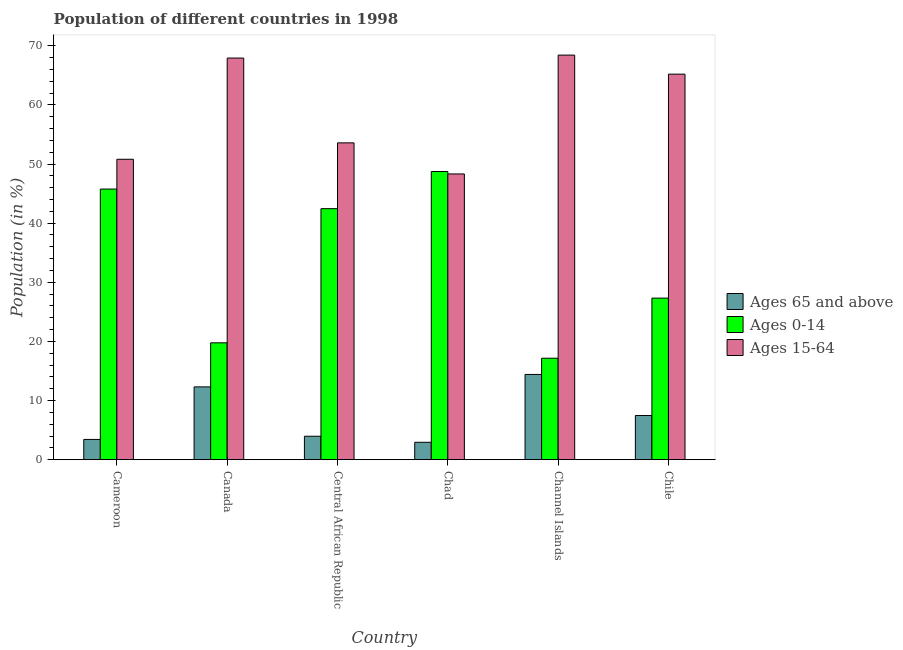How many different coloured bars are there?
Make the answer very short. 3. Are the number of bars on each tick of the X-axis equal?
Your answer should be compact. Yes. What is the label of the 4th group of bars from the left?
Provide a short and direct response. Chad. In how many cases, is the number of bars for a given country not equal to the number of legend labels?
Your answer should be compact. 0. What is the percentage of population within the age-group 15-64 in Chad?
Keep it short and to the point. 48.32. Across all countries, what is the maximum percentage of population within the age-group 15-64?
Provide a short and direct response. 68.42. Across all countries, what is the minimum percentage of population within the age-group 15-64?
Give a very brief answer. 48.32. In which country was the percentage of population within the age-group 15-64 maximum?
Provide a succinct answer. Channel Islands. In which country was the percentage of population within the age-group of 65 and above minimum?
Make the answer very short. Chad. What is the total percentage of population within the age-group of 65 and above in the graph?
Offer a very short reply. 44.55. What is the difference between the percentage of population within the age-group of 65 and above in Chad and that in Channel Islands?
Make the answer very short. -11.47. What is the difference between the percentage of population within the age-group of 65 and above in Chile and the percentage of population within the age-group 0-14 in Central African Republic?
Provide a short and direct response. -34.98. What is the average percentage of population within the age-group 0-14 per country?
Make the answer very short. 33.53. What is the difference between the percentage of population within the age-group of 65 and above and percentage of population within the age-group 15-64 in Canada?
Ensure brevity in your answer.  -55.61. In how many countries, is the percentage of population within the age-group 0-14 greater than 62 %?
Your answer should be compact. 0. What is the ratio of the percentage of population within the age-group 15-64 in Cameroon to that in Central African Republic?
Give a very brief answer. 0.95. Is the difference between the percentage of population within the age-group 0-14 in Cameroon and Chad greater than the difference between the percentage of population within the age-group of 65 and above in Cameroon and Chad?
Provide a short and direct response. No. What is the difference between the highest and the second highest percentage of population within the age-group of 65 and above?
Your response must be concise. 2.11. What is the difference between the highest and the lowest percentage of population within the age-group of 65 and above?
Offer a very short reply. 11.47. What does the 1st bar from the left in Cameroon represents?
Your answer should be very brief. Ages 65 and above. What does the 1st bar from the right in Channel Islands represents?
Provide a succinct answer. Ages 15-64. Are all the bars in the graph horizontal?
Provide a short and direct response. No. How many countries are there in the graph?
Ensure brevity in your answer.  6. Does the graph contain any zero values?
Keep it short and to the point. No. Does the graph contain grids?
Keep it short and to the point. No. What is the title of the graph?
Your response must be concise. Population of different countries in 1998. Does "Infant(male)" appear as one of the legend labels in the graph?
Offer a very short reply. No. What is the Population (in %) in Ages 65 and above in Cameroon?
Provide a succinct answer. 3.43. What is the Population (in %) in Ages 0-14 in Cameroon?
Ensure brevity in your answer.  45.77. What is the Population (in %) of Ages 15-64 in Cameroon?
Offer a terse response. 50.8. What is the Population (in %) of Ages 65 and above in Canada?
Provide a succinct answer. 12.31. What is the Population (in %) of Ages 0-14 in Canada?
Offer a very short reply. 19.76. What is the Population (in %) of Ages 15-64 in Canada?
Provide a short and direct response. 67.92. What is the Population (in %) of Ages 65 and above in Central African Republic?
Keep it short and to the point. 3.97. What is the Population (in %) of Ages 0-14 in Central African Republic?
Ensure brevity in your answer.  42.45. What is the Population (in %) of Ages 15-64 in Central African Republic?
Offer a terse response. 53.58. What is the Population (in %) in Ages 65 and above in Chad?
Keep it short and to the point. 2.94. What is the Population (in %) in Ages 0-14 in Chad?
Your answer should be compact. 48.73. What is the Population (in %) of Ages 15-64 in Chad?
Your answer should be compact. 48.32. What is the Population (in %) in Ages 65 and above in Channel Islands?
Provide a succinct answer. 14.42. What is the Population (in %) of Ages 0-14 in Channel Islands?
Ensure brevity in your answer.  17.16. What is the Population (in %) of Ages 15-64 in Channel Islands?
Provide a succinct answer. 68.42. What is the Population (in %) in Ages 65 and above in Chile?
Ensure brevity in your answer.  7.48. What is the Population (in %) of Ages 0-14 in Chile?
Offer a terse response. 27.32. What is the Population (in %) in Ages 15-64 in Chile?
Your response must be concise. 65.2. Across all countries, what is the maximum Population (in %) in Ages 65 and above?
Ensure brevity in your answer.  14.42. Across all countries, what is the maximum Population (in %) in Ages 0-14?
Your response must be concise. 48.73. Across all countries, what is the maximum Population (in %) in Ages 15-64?
Keep it short and to the point. 68.42. Across all countries, what is the minimum Population (in %) in Ages 65 and above?
Make the answer very short. 2.94. Across all countries, what is the minimum Population (in %) in Ages 0-14?
Keep it short and to the point. 17.16. Across all countries, what is the minimum Population (in %) of Ages 15-64?
Offer a terse response. 48.32. What is the total Population (in %) in Ages 65 and above in the graph?
Your answer should be compact. 44.55. What is the total Population (in %) of Ages 0-14 in the graph?
Provide a short and direct response. 201.2. What is the total Population (in %) in Ages 15-64 in the graph?
Your answer should be very brief. 354.25. What is the difference between the Population (in %) in Ages 65 and above in Cameroon and that in Canada?
Give a very brief answer. -8.89. What is the difference between the Population (in %) of Ages 0-14 in Cameroon and that in Canada?
Offer a terse response. 26. What is the difference between the Population (in %) of Ages 15-64 in Cameroon and that in Canada?
Offer a terse response. -17.12. What is the difference between the Population (in %) in Ages 65 and above in Cameroon and that in Central African Republic?
Offer a very short reply. -0.54. What is the difference between the Population (in %) in Ages 0-14 in Cameroon and that in Central African Republic?
Your answer should be compact. 3.32. What is the difference between the Population (in %) in Ages 15-64 in Cameroon and that in Central African Republic?
Your answer should be compact. -2.78. What is the difference between the Population (in %) of Ages 65 and above in Cameroon and that in Chad?
Provide a succinct answer. 0.48. What is the difference between the Population (in %) of Ages 0-14 in Cameroon and that in Chad?
Your response must be concise. -2.96. What is the difference between the Population (in %) of Ages 15-64 in Cameroon and that in Chad?
Your answer should be very brief. 2.48. What is the difference between the Population (in %) of Ages 65 and above in Cameroon and that in Channel Islands?
Provide a short and direct response. -10.99. What is the difference between the Population (in %) of Ages 0-14 in Cameroon and that in Channel Islands?
Your answer should be very brief. 28.61. What is the difference between the Population (in %) in Ages 15-64 in Cameroon and that in Channel Islands?
Your answer should be compact. -17.62. What is the difference between the Population (in %) of Ages 65 and above in Cameroon and that in Chile?
Provide a short and direct response. -4.05. What is the difference between the Population (in %) of Ages 0-14 in Cameroon and that in Chile?
Ensure brevity in your answer.  18.44. What is the difference between the Population (in %) in Ages 15-64 in Cameroon and that in Chile?
Give a very brief answer. -14.39. What is the difference between the Population (in %) in Ages 65 and above in Canada and that in Central African Republic?
Provide a succinct answer. 8.35. What is the difference between the Population (in %) of Ages 0-14 in Canada and that in Central African Republic?
Make the answer very short. -22.69. What is the difference between the Population (in %) of Ages 15-64 in Canada and that in Central African Republic?
Provide a short and direct response. 14.34. What is the difference between the Population (in %) of Ages 65 and above in Canada and that in Chad?
Give a very brief answer. 9.37. What is the difference between the Population (in %) in Ages 0-14 in Canada and that in Chad?
Ensure brevity in your answer.  -28.97. What is the difference between the Population (in %) of Ages 15-64 in Canada and that in Chad?
Make the answer very short. 19.6. What is the difference between the Population (in %) in Ages 65 and above in Canada and that in Channel Islands?
Your answer should be very brief. -2.1. What is the difference between the Population (in %) in Ages 0-14 in Canada and that in Channel Islands?
Your answer should be compact. 2.6. What is the difference between the Population (in %) of Ages 15-64 in Canada and that in Channel Islands?
Your response must be concise. -0.5. What is the difference between the Population (in %) in Ages 65 and above in Canada and that in Chile?
Keep it short and to the point. 4.84. What is the difference between the Population (in %) of Ages 0-14 in Canada and that in Chile?
Provide a succinct answer. -7.56. What is the difference between the Population (in %) in Ages 15-64 in Canada and that in Chile?
Your answer should be very brief. 2.72. What is the difference between the Population (in %) in Ages 65 and above in Central African Republic and that in Chad?
Your answer should be compact. 1.02. What is the difference between the Population (in %) of Ages 0-14 in Central African Republic and that in Chad?
Offer a very short reply. -6.28. What is the difference between the Population (in %) of Ages 15-64 in Central African Republic and that in Chad?
Your response must be concise. 5.26. What is the difference between the Population (in %) of Ages 65 and above in Central African Republic and that in Channel Islands?
Your answer should be compact. -10.45. What is the difference between the Population (in %) in Ages 0-14 in Central African Republic and that in Channel Islands?
Your response must be concise. 25.29. What is the difference between the Population (in %) in Ages 15-64 in Central African Republic and that in Channel Islands?
Your answer should be compact. -14.84. What is the difference between the Population (in %) in Ages 65 and above in Central African Republic and that in Chile?
Make the answer very short. -3.51. What is the difference between the Population (in %) of Ages 0-14 in Central African Republic and that in Chile?
Offer a terse response. 15.13. What is the difference between the Population (in %) of Ages 15-64 in Central African Republic and that in Chile?
Ensure brevity in your answer.  -11.62. What is the difference between the Population (in %) in Ages 65 and above in Chad and that in Channel Islands?
Keep it short and to the point. -11.47. What is the difference between the Population (in %) in Ages 0-14 in Chad and that in Channel Islands?
Keep it short and to the point. 31.57. What is the difference between the Population (in %) of Ages 15-64 in Chad and that in Channel Islands?
Make the answer very short. -20.1. What is the difference between the Population (in %) of Ages 65 and above in Chad and that in Chile?
Keep it short and to the point. -4.53. What is the difference between the Population (in %) in Ages 0-14 in Chad and that in Chile?
Ensure brevity in your answer.  21.41. What is the difference between the Population (in %) in Ages 15-64 in Chad and that in Chile?
Provide a short and direct response. -16.88. What is the difference between the Population (in %) of Ages 65 and above in Channel Islands and that in Chile?
Keep it short and to the point. 6.94. What is the difference between the Population (in %) of Ages 0-14 in Channel Islands and that in Chile?
Make the answer very short. -10.16. What is the difference between the Population (in %) of Ages 15-64 in Channel Islands and that in Chile?
Give a very brief answer. 3.22. What is the difference between the Population (in %) of Ages 65 and above in Cameroon and the Population (in %) of Ages 0-14 in Canada?
Give a very brief answer. -16.34. What is the difference between the Population (in %) of Ages 65 and above in Cameroon and the Population (in %) of Ages 15-64 in Canada?
Keep it short and to the point. -64.5. What is the difference between the Population (in %) of Ages 0-14 in Cameroon and the Population (in %) of Ages 15-64 in Canada?
Offer a very short reply. -22.15. What is the difference between the Population (in %) of Ages 65 and above in Cameroon and the Population (in %) of Ages 0-14 in Central African Republic?
Offer a terse response. -39.03. What is the difference between the Population (in %) in Ages 65 and above in Cameroon and the Population (in %) in Ages 15-64 in Central African Republic?
Keep it short and to the point. -50.15. What is the difference between the Population (in %) of Ages 0-14 in Cameroon and the Population (in %) of Ages 15-64 in Central African Republic?
Keep it short and to the point. -7.81. What is the difference between the Population (in %) in Ages 65 and above in Cameroon and the Population (in %) in Ages 0-14 in Chad?
Ensure brevity in your answer.  -45.31. What is the difference between the Population (in %) in Ages 65 and above in Cameroon and the Population (in %) in Ages 15-64 in Chad?
Your response must be concise. -44.9. What is the difference between the Population (in %) of Ages 0-14 in Cameroon and the Population (in %) of Ages 15-64 in Chad?
Offer a terse response. -2.56. What is the difference between the Population (in %) of Ages 65 and above in Cameroon and the Population (in %) of Ages 0-14 in Channel Islands?
Provide a short and direct response. -13.73. What is the difference between the Population (in %) of Ages 65 and above in Cameroon and the Population (in %) of Ages 15-64 in Channel Islands?
Your answer should be compact. -64.99. What is the difference between the Population (in %) in Ages 0-14 in Cameroon and the Population (in %) in Ages 15-64 in Channel Islands?
Ensure brevity in your answer.  -22.65. What is the difference between the Population (in %) in Ages 65 and above in Cameroon and the Population (in %) in Ages 0-14 in Chile?
Offer a terse response. -23.9. What is the difference between the Population (in %) in Ages 65 and above in Cameroon and the Population (in %) in Ages 15-64 in Chile?
Ensure brevity in your answer.  -61.77. What is the difference between the Population (in %) of Ages 0-14 in Cameroon and the Population (in %) of Ages 15-64 in Chile?
Ensure brevity in your answer.  -19.43. What is the difference between the Population (in %) in Ages 65 and above in Canada and the Population (in %) in Ages 0-14 in Central African Republic?
Offer a terse response. -30.14. What is the difference between the Population (in %) in Ages 65 and above in Canada and the Population (in %) in Ages 15-64 in Central African Republic?
Ensure brevity in your answer.  -41.27. What is the difference between the Population (in %) of Ages 0-14 in Canada and the Population (in %) of Ages 15-64 in Central African Republic?
Give a very brief answer. -33.82. What is the difference between the Population (in %) of Ages 65 and above in Canada and the Population (in %) of Ages 0-14 in Chad?
Offer a very short reply. -36.42. What is the difference between the Population (in %) of Ages 65 and above in Canada and the Population (in %) of Ages 15-64 in Chad?
Offer a very short reply. -36.01. What is the difference between the Population (in %) in Ages 0-14 in Canada and the Population (in %) in Ages 15-64 in Chad?
Keep it short and to the point. -28.56. What is the difference between the Population (in %) of Ages 65 and above in Canada and the Population (in %) of Ages 0-14 in Channel Islands?
Your answer should be compact. -4.85. What is the difference between the Population (in %) in Ages 65 and above in Canada and the Population (in %) in Ages 15-64 in Channel Islands?
Your answer should be compact. -56.11. What is the difference between the Population (in %) of Ages 0-14 in Canada and the Population (in %) of Ages 15-64 in Channel Islands?
Provide a succinct answer. -48.66. What is the difference between the Population (in %) in Ages 65 and above in Canada and the Population (in %) in Ages 0-14 in Chile?
Provide a succinct answer. -15.01. What is the difference between the Population (in %) of Ages 65 and above in Canada and the Population (in %) of Ages 15-64 in Chile?
Provide a succinct answer. -52.89. What is the difference between the Population (in %) in Ages 0-14 in Canada and the Population (in %) in Ages 15-64 in Chile?
Provide a succinct answer. -45.43. What is the difference between the Population (in %) in Ages 65 and above in Central African Republic and the Population (in %) in Ages 0-14 in Chad?
Give a very brief answer. -44.77. What is the difference between the Population (in %) of Ages 65 and above in Central African Republic and the Population (in %) of Ages 15-64 in Chad?
Give a very brief answer. -44.36. What is the difference between the Population (in %) of Ages 0-14 in Central African Republic and the Population (in %) of Ages 15-64 in Chad?
Provide a succinct answer. -5.87. What is the difference between the Population (in %) in Ages 65 and above in Central African Republic and the Population (in %) in Ages 0-14 in Channel Islands?
Your response must be concise. -13.19. What is the difference between the Population (in %) in Ages 65 and above in Central African Republic and the Population (in %) in Ages 15-64 in Channel Islands?
Offer a terse response. -64.45. What is the difference between the Population (in %) of Ages 0-14 in Central African Republic and the Population (in %) of Ages 15-64 in Channel Islands?
Give a very brief answer. -25.97. What is the difference between the Population (in %) of Ages 65 and above in Central African Republic and the Population (in %) of Ages 0-14 in Chile?
Your response must be concise. -23.36. What is the difference between the Population (in %) in Ages 65 and above in Central African Republic and the Population (in %) in Ages 15-64 in Chile?
Provide a succinct answer. -61.23. What is the difference between the Population (in %) of Ages 0-14 in Central African Republic and the Population (in %) of Ages 15-64 in Chile?
Provide a short and direct response. -22.75. What is the difference between the Population (in %) of Ages 65 and above in Chad and the Population (in %) of Ages 0-14 in Channel Islands?
Ensure brevity in your answer.  -14.22. What is the difference between the Population (in %) in Ages 65 and above in Chad and the Population (in %) in Ages 15-64 in Channel Islands?
Offer a terse response. -65.48. What is the difference between the Population (in %) in Ages 0-14 in Chad and the Population (in %) in Ages 15-64 in Channel Islands?
Your answer should be very brief. -19.69. What is the difference between the Population (in %) in Ages 65 and above in Chad and the Population (in %) in Ages 0-14 in Chile?
Make the answer very short. -24.38. What is the difference between the Population (in %) of Ages 65 and above in Chad and the Population (in %) of Ages 15-64 in Chile?
Your response must be concise. -62.26. What is the difference between the Population (in %) in Ages 0-14 in Chad and the Population (in %) in Ages 15-64 in Chile?
Keep it short and to the point. -16.47. What is the difference between the Population (in %) of Ages 65 and above in Channel Islands and the Population (in %) of Ages 0-14 in Chile?
Your response must be concise. -12.91. What is the difference between the Population (in %) of Ages 65 and above in Channel Islands and the Population (in %) of Ages 15-64 in Chile?
Your response must be concise. -50.78. What is the difference between the Population (in %) of Ages 0-14 in Channel Islands and the Population (in %) of Ages 15-64 in Chile?
Your answer should be very brief. -48.04. What is the average Population (in %) in Ages 65 and above per country?
Keep it short and to the point. 7.42. What is the average Population (in %) in Ages 0-14 per country?
Your response must be concise. 33.53. What is the average Population (in %) of Ages 15-64 per country?
Make the answer very short. 59.04. What is the difference between the Population (in %) of Ages 65 and above and Population (in %) of Ages 0-14 in Cameroon?
Your answer should be compact. -42.34. What is the difference between the Population (in %) in Ages 65 and above and Population (in %) in Ages 15-64 in Cameroon?
Provide a succinct answer. -47.38. What is the difference between the Population (in %) in Ages 0-14 and Population (in %) in Ages 15-64 in Cameroon?
Your answer should be compact. -5.04. What is the difference between the Population (in %) of Ages 65 and above and Population (in %) of Ages 0-14 in Canada?
Your response must be concise. -7.45. What is the difference between the Population (in %) of Ages 65 and above and Population (in %) of Ages 15-64 in Canada?
Make the answer very short. -55.61. What is the difference between the Population (in %) of Ages 0-14 and Population (in %) of Ages 15-64 in Canada?
Give a very brief answer. -48.16. What is the difference between the Population (in %) of Ages 65 and above and Population (in %) of Ages 0-14 in Central African Republic?
Offer a terse response. -38.49. What is the difference between the Population (in %) in Ages 65 and above and Population (in %) in Ages 15-64 in Central African Republic?
Make the answer very short. -49.61. What is the difference between the Population (in %) in Ages 0-14 and Population (in %) in Ages 15-64 in Central African Republic?
Your response must be concise. -11.13. What is the difference between the Population (in %) of Ages 65 and above and Population (in %) of Ages 0-14 in Chad?
Your response must be concise. -45.79. What is the difference between the Population (in %) in Ages 65 and above and Population (in %) in Ages 15-64 in Chad?
Offer a terse response. -45.38. What is the difference between the Population (in %) in Ages 0-14 and Population (in %) in Ages 15-64 in Chad?
Keep it short and to the point. 0.41. What is the difference between the Population (in %) in Ages 65 and above and Population (in %) in Ages 0-14 in Channel Islands?
Offer a terse response. -2.74. What is the difference between the Population (in %) in Ages 65 and above and Population (in %) in Ages 15-64 in Channel Islands?
Keep it short and to the point. -54. What is the difference between the Population (in %) in Ages 0-14 and Population (in %) in Ages 15-64 in Channel Islands?
Your answer should be very brief. -51.26. What is the difference between the Population (in %) of Ages 65 and above and Population (in %) of Ages 0-14 in Chile?
Make the answer very short. -19.85. What is the difference between the Population (in %) of Ages 65 and above and Population (in %) of Ages 15-64 in Chile?
Keep it short and to the point. -57.72. What is the difference between the Population (in %) in Ages 0-14 and Population (in %) in Ages 15-64 in Chile?
Offer a very short reply. -37.88. What is the ratio of the Population (in %) in Ages 65 and above in Cameroon to that in Canada?
Ensure brevity in your answer.  0.28. What is the ratio of the Population (in %) of Ages 0-14 in Cameroon to that in Canada?
Provide a succinct answer. 2.32. What is the ratio of the Population (in %) of Ages 15-64 in Cameroon to that in Canada?
Make the answer very short. 0.75. What is the ratio of the Population (in %) in Ages 65 and above in Cameroon to that in Central African Republic?
Provide a succinct answer. 0.86. What is the ratio of the Population (in %) of Ages 0-14 in Cameroon to that in Central African Republic?
Your answer should be compact. 1.08. What is the ratio of the Population (in %) in Ages 15-64 in Cameroon to that in Central African Republic?
Ensure brevity in your answer.  0.95. What is the ratio of the Population (in %) in Ages 65 and above in Cameroon to that in Chad?
Your answer should be compact. 1.16. What is the ratio of the Population (in %) of Ages 0-14 in Cameroon to that in Chad?
Offer a terse response. 0.94. What is the ratio of the Population (in %) in Ages 15-64 in Cameroon to that in Chad?
Your answer should be compact. 1.05. What is the ratio of the Population (in %) in Ages 65 and above in Cameroon to that in Channel Islands?
Offer a very short reply. 0.24. What is the ratio of the Population (in %) in Ages 0-14 in Cameroon to that in Channel Islands?
Your response must be concise. 2.67. What is the ratio of the Population (in %) of Ages 15-64 in Cameroon to that in Channel Islands?
Make the answer very short. 0.74. What is the ratio of the Population (in %) in Ages 65 and above in Cameroon to that in Chile?
Offer a very short reply. 0.46. What is the ratio of the Population (in %) of Ages 0-14 in Cameroon to that in Chile?
Offer a very short reply. 1.68. What is the ratio of the Population (in %) in Ages 15-64 in Cameroon to that in Chile?
Keep it short and to the point. 0.78. What is the ratio of the Population (in %) of Ages 65 and above in Canada to that in Central African Republic?
Make the answer very short. 3.1. What is the ratio of the Population (in %) of Ages 0-14 in Canada to that in Central African Republic?
Ensure brevity in your answer.  0.47. What is the ratio of the Population (in %) in Ages 15-64 in Canada to that in Central African Republic?
Offer a terse response. 1.27. What is the ratio of the Population (in %) in Ages 65 and above in Canada to that in Chad?
Provide a succinct answer. 4.18. What is the ratio of the Population (in %) of Ages 0-14 in Canada to that in Chad?
Your answer should be very brief. 0.41. What is the ratio of the Population (in %) of Ages 15-64 in Canada to that in Chad?
Your answer should be compact. 1.41. What is the ratio of the Population (in %) of Ages 65 and above in Canada to that in Channel Islands?
Ensure brevity in your answer.  0.85. What is the ratio of the Population (in %) in Ages 0-14 in Canada to that in Channel Islands?
Your answer should be compact. 1.15. What is the ratio of the Population (in %) of Ages 15-64 in Canada to that in Channel Islands?
Provide a short and direct response. 0.99. What is the ratio of the Population (in %) in Ages 65 and above in Canada to that in Chile?
Keep it short and to the point. 1.65. What is the ratio of the Population (in %) in Ages 0-14 in Canada to that in Chile?
Keep it short and to the point. 0.72. What is the ratio of the Population (in %) of Ages 15-64 in Canada to that in Chile?
Keep it short and to the point. 1.04. What is the ratio of the Population (in %) of Ages 65 and above in Central African Republic to that in Chad?
Your answer should be very brief. 1.35. What is the ratio of the Population (in %) of Ages 0-14 in Central African Republic to that in Chad?
Make the answer very short. 0.87. What is the ratio of the Population (in %) of Ages 15-64 in Central African Republic to that in Chad?
Your answer should be compact. 1.11. What is the ratio of the Population (in %) of Ages 65 and above in Central African Republic to that in Channel Islands?
Offer a terse response. 0.28. What is the ratio of the Population (in %) in Ages 0-14 in Central African Republic to that in Channel Islands?
Provide a succinct answer. 2.47. What is the ratio of the Population (in %) of Ages 15-64 in Central African Republic to that in Channel Islands?
Ensure brevity in your answer.  0.78. What is the ratio of the Population (in %) of Ages 65 and above in Central African Republic to that in Chile?
Offer a terse response. 0.53. What is the ratio of the Population (in %) of Ages 0-14 in Central African Republic to that in Chile?
Offer a very short reply. 1.55. What is the ratio of the Population (in %) of Ages 15-64 in Central African Republic to that in Chile?
Offer a very short reply. 0.82. What is the ratio of the Population (in %) in Ages 65 and above in Chad to that in Channel Islands?
Ensure brevity in your answer.  0.2. What is the ratio of the Population (in %) in Ages 0-14 in Chad to that in Channel Islands?
Your answer should be very brief. 2.84. What is the ratio of the Population (in %) in Ages 15-64 in Chad to that in Channel Islands?
Keep it short and to the point. 0.71. What is the ratio of the Population (in %) in Ages 65 and above in Chad to that in Chile?
Provide a succinct answer. 0.39. What is the ratio of the Population (in %) in Ages 0-14 in Chad to that in Chile?
Offer a very short reply. 1.78. What is the ratio of the Population (in %) in Ages 15-64 in Chad to that in Chile?
Make the answer very short. 0.74. What is the ratio of the Population (in %) in Ages 65 and above in Channel Islands to that in Chile?
Offer a terse response. 1.93. What is the ratio of the Population (in %) of Ages 0-14 in Channel Islands to that in Chile?
Give a very brief answer. 0.63. What is the ratio of the Population (in %) in Ages 15-64 in Channel Islands to that in Chile?
Give a very brief answer. 1.05. What is the difference between the highest and the second highest Population (in %) of Ages 65 and above?
Ensure brevity in your answer.  2.1. What is the difference between the highest and the second highest Population (in %) in Ages 0-14?
Ensure brevity in your answer.  2.96. What is the difference between the highest and the second highest Population (in %) of Ages 15-64?
Offer a very short reply. 0.5. What is the difference between the highest and the lowest Population (in %) in Ages 65 and above?
Provide a short and direct response. 11.47. What is the difference between the highest and the lowest Population (in %) of Ages 0-14?
Offer a very short reply. 31.57. What is the difference between the highest and the lowest Population (in %) of Ages 15-64?
Keep it short and to the point. 20.1. 